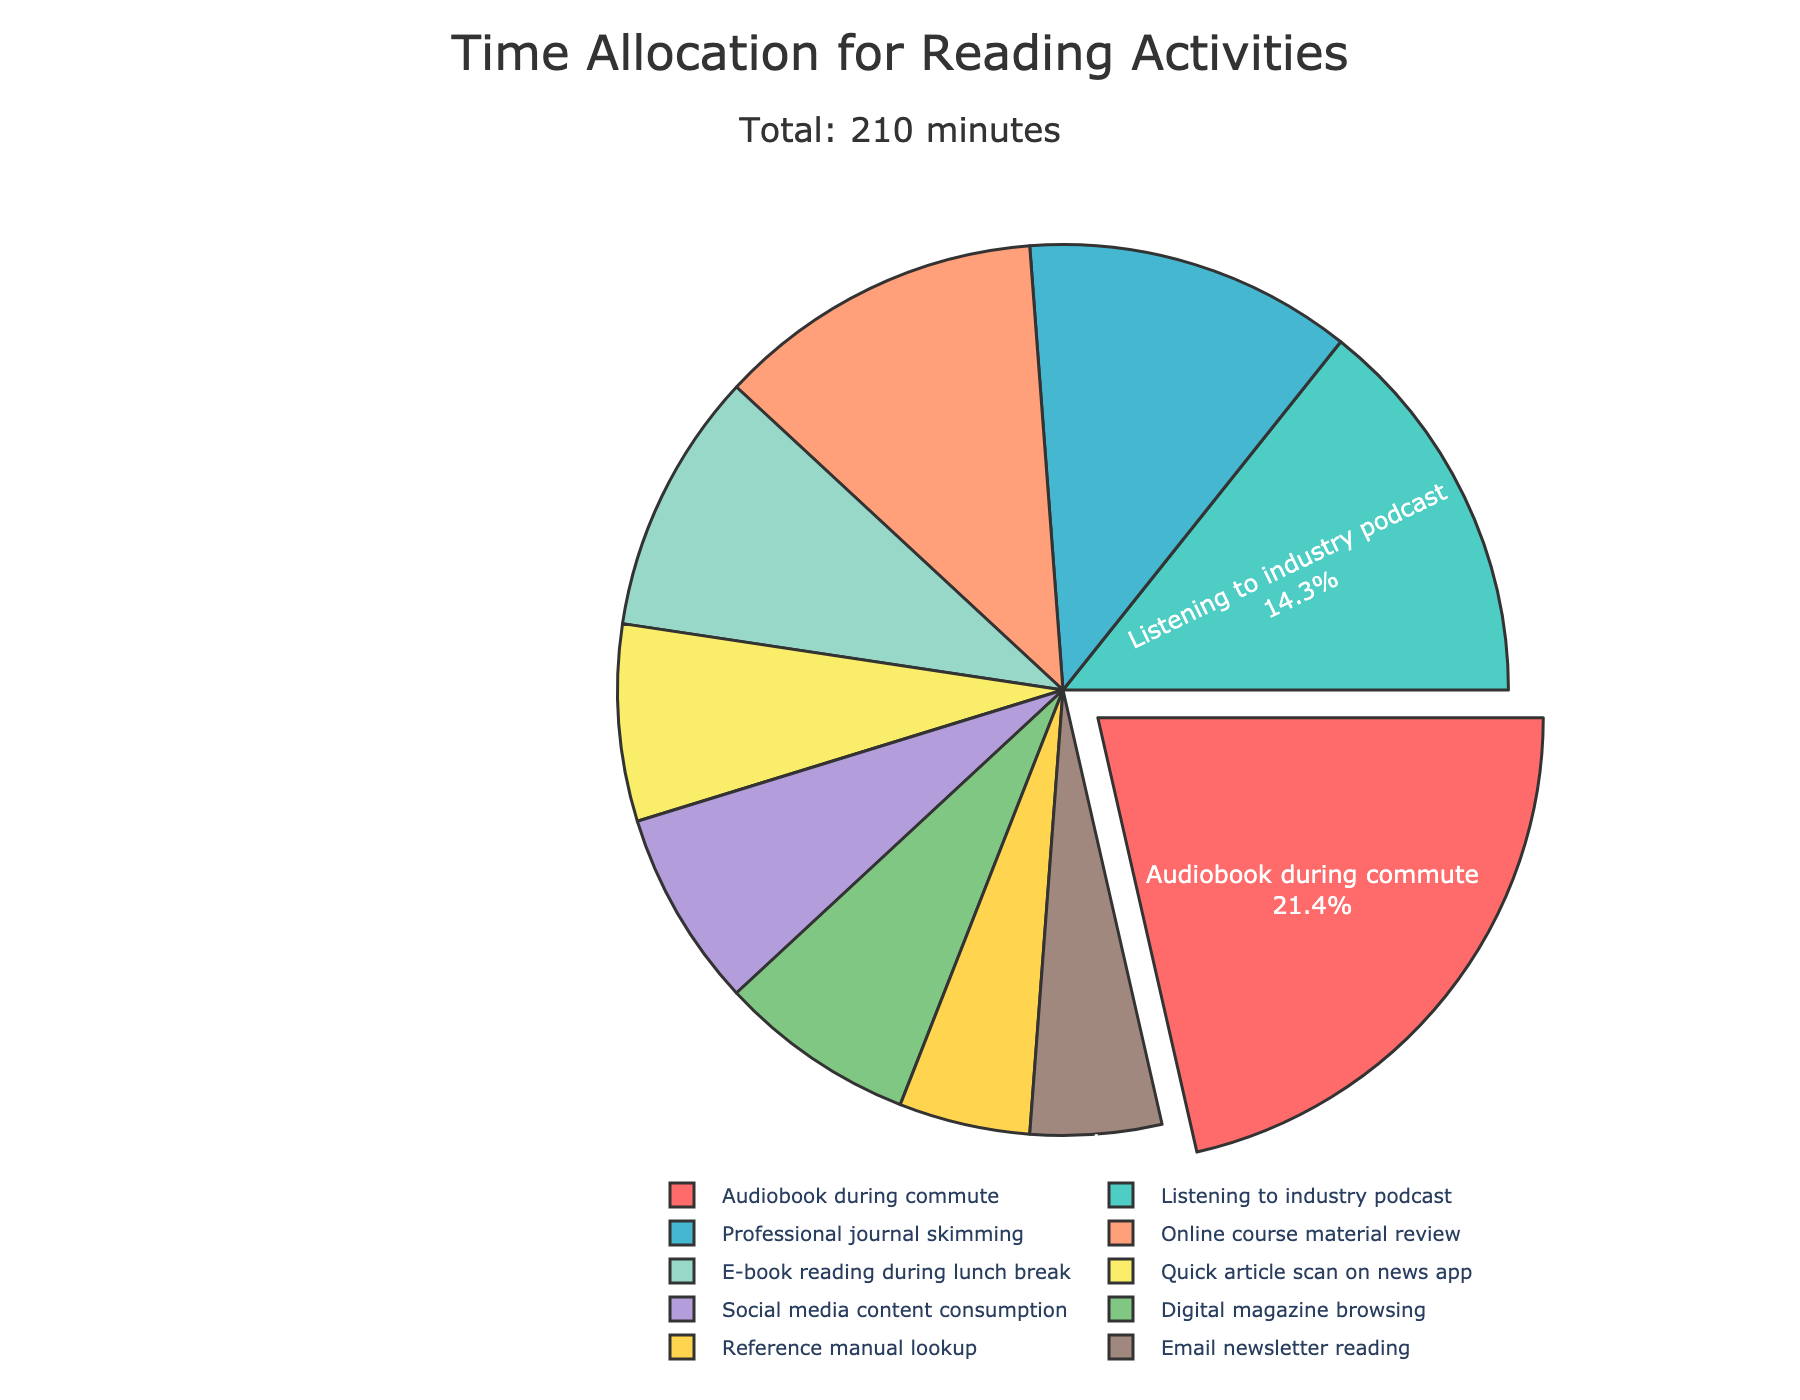What's the largest time allocation for a single activity? The largest segment is visually separated by a gap (pulled out) and shows that the most time-consuming activity is "Audiobook during commute" with 45 minutes.
Answer: Audiobook during commute Which reading activities take up 25 minutes each? By looking at the pie chart, the activities with 25 minutes allocated each are "Professional journal skimming" and "Online course material review."
Answer: Professional journal skimming, Online course material review What percentage of the total time is spent on Professional journal skimming? The pie chart displays the percentage values on each segment. The segment for "Professional journal skimming" shows that it takes up 14.7% of the total time.
Answer: 14.7% How much more time is spent on Audiobooks during commute compared to E-book reading during lunch break? Time spent on Audiobooks during commute is 45 minutes and on E-book reading during lunch break is 20 minutes. Subtract the latter from the former: 45 - 20 = 25 minutes.
Answer: 25 minutes What activities together make up exactly half of the reading time? Total reading time is 210 minutes. Half of this is 105 minutes. Adding from the largest segments: Audiobook during commute (45) + Listening to industry podcast (30) + Online course material review (25) + one additional activity (Reference manual lookup 10) = 45 + 30 + 25 + 5 = 105 minutes.
Answer: Audiobook during commute, Listening to industry podcast, Online course material review, Reference manual lookup Which segment has a yellow color and how long is it? The yellow segment can be visually identified as "F9ED69" in color and signifies "Listening to industry podcast" which lasts for 30 minutes.
Answer: Listening to industry podcast, 30 minutes Among all activities, which three together account for the smallest total reading time? The smallest segments are for "Social media content consumption" (15), "Email newsletter reading" (10), and "Reference manual lookup" (10). Summing them: 15 + 10 + 10 = 35 minutes.
Answer: Social media content consumption, Email newsletter reading, Reference manual lookup What is the exact duration in minutes apart from the total time taken by Audiobook during commute and Listening to industry podcast? Subtract the sum of Audiobook during commute (45) and Listening to industry podcast (30) from the total time 210: 210 - (45 + 30) = 135 minutes.
Answer: 135 minutes How does the time spent on Digital magazine browsing compare to Reference manual lookup and Email newsletter reading combined? Time for Digital magazine browsing is 15 minutes. Time for Reference manual lookup and Email newsletter reading combined is 10 + 10 = 20 minutes. Comparing: 15 < 20.
Answer: Less Which activities take between 10 and 30 minutes of reading time each? We need to check each segment for time values falling within 10 to 30 minutes. The activities are: E-book reading during lunch break (20), Quick article scan on news app (15), Professional journal skimming (25), Listening to industry podcast (30), Social media content consumption (15), Email newsletter reading (10), Digital magazine browsing (15), and Reference manual lookup (10).
Answer: E-book reading during lunch break, Quick article scan on news app, Professional journal skimming, Listening to industry podcast, Social media content consumption, Email newsletter reading, Digital magazine browsing, Reference manual lookup 